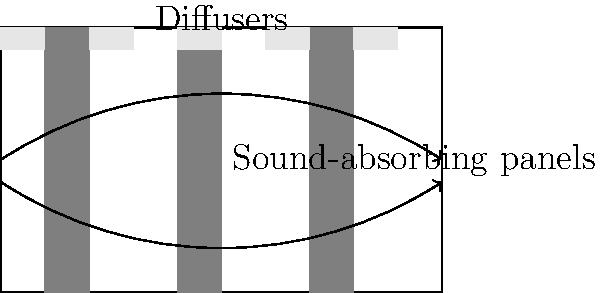As a veteran director, you're consulting on the design of a new indoor sound stage. The architects have proposed the layout shown in the diagram, featuring sound-absorbing panels on the walls and diffusers on the ceiling. What is the primary purpose of the ceiling diffusers in optimizing the acoustics of this space? To understand the purpose of ceiling diffusers in optimizing the acoustics of an indoor sound stage, let's break down the acoustic considerations:

1. Sound reflection: In an enclosed space, sound waves bounce off surfaces, creating reflections and echoes.

2. Sound absorption: The gray panels on the walls are sound-absorbing materials that reduce reflected sound energy.

3. Sound diffusion: The ceiling diffusers serve a different purpose than the absorbing panels.

4. Role of diffusers:
   a) They scatter sound waves in multiple directions, rather than reflecting them at a single angle.
   b) This scattering helps to distribute sound energy more evenly throughout the space.
   c) By breaking up strong reflections, diffusers reduce the risk of standing waves and flutter echoes.

5. Benefits in a sound stage:
   a) Improved sound clarity: By reducing strong reflections, diffusers help maintain the integrity of recorded sound.
   b) Enhanced spatial perception: The scattered reflections create a sense of spaciousness without excessive reverberation.
   c) Balanced frequency response: Diffusers can be designed to scatter different frequencies, ensuring a more even sound across the spectrum.

6. Ceiling placement:
   a) Placing diffusers on the ceiling helps to break up reflections between parallel surfaces (floor and ceiling).
   b) This placement complements the absorbing panels on the walls, creating a well-rounded acoustic treatment.

In summary, the primary purpose of the ceiling diffusers is to scatter sound waves, creating a more even and natural-sounding acoustic environment within the sound stage.
Answer: To scatter sound waves, creating an even distribution of sound energy and reducing strong reflections. 